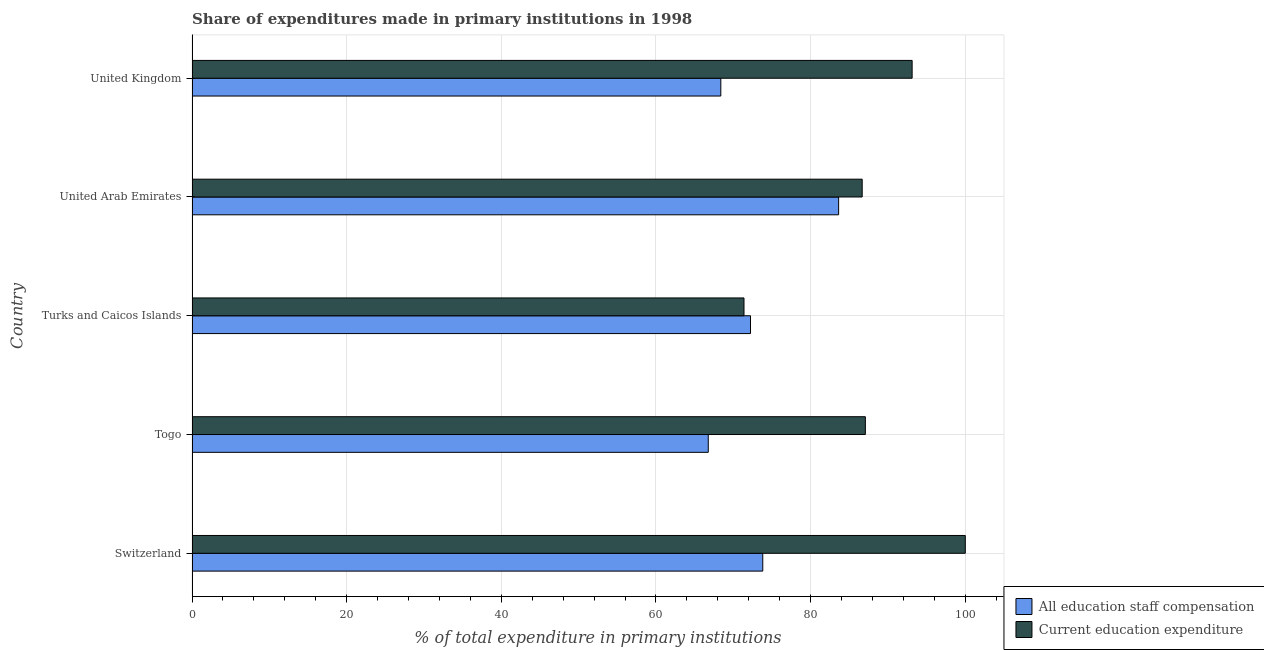How many different coloured bars are there?
Provide a succinct answer. 2. How many groups of bars are there?
Your response must be concise. 5. Are the number of bars per tick equal to the number of legend labels?
Ensure brevity in your answer.  Yes. Are the number of bars on each tick of the Y-axis equal?
Offer a very short reply. Yes. How many bars are there on the 1st tick from the top?
Provide a short and direct response. 2. What is the expenditure in staff compensation in Togo?
Your response must be concise. 66.76. Across all countries, what is the maximum expenditure in staff compensation?
Your response must be concise. 83.62. Across all countries, what is the minimum expenditure in staff compensation?
Make the answer very short. 66.76. In which country was the expenditure in staff compensation maximum?
Ensure brevity in your answer.  United Arab Emirates. In which country was the expenditure in staff compensation minimum?
Make the answer very short. Togo. What is the total expenditure in education in the graph?
Ensure brevity in your answer.  438.25. What is the difference between the expenditure in education in Switzerland and that in United Arab Emirates?
Give a very brief answer. 13.33. What is the difference between the expenditure in education in Turks and Caicos Islands and the expenditure in staff compensation in Switzerland?
Keep it short and to the point. -2.43. What is the average expenditure in staff compensation per country?
Your answer should be very brief. 72.96. What is the difference between the expenditure in education and expenditure in staff compensation in Switzerland?
Offer a terse response. 26.19. What is the ratio of the expenditure in staff compensation in Turks and Caicos Islands to that in United Kingdom?
Your answer should be very brief. 1.06. Is the difference between the expenditure in staff compensation in Turks and Caicos Islands and United Kingdom greater than the difference between the expenditure in education in Turks and Caicos Islands and United Kingdom?
Offer a very short reply. Yes. What is the difference between the highest and the second highest expenditure in education?
Ensure brevity in your answer.  6.87. What is the difference between the highest and the lowest expenditure in staff compensation?
Keep it short and to the point. 16.86. Is the sum of the expenditure in education in Switzerland and United Kingdom greater than the maximum expenditure in staff compensation across all countries?
Your response must be concise. Yes. What does the 1st bar from the top in Switzerland represents?
Offer a terse response. Current education expenditure. What does the 1st bar from the bottom in Togo represents?
Your answer should be very brief. All education staff compensation. Does the graph contain any zero values?
Make the answer very short. No. Does the graph contain grids?
Offer a very short reply. Yes. Where does the legend appear in the graph?
Your answer should be compact. Bottom right. How many legend labels are there?
Your answer should be very brief. 2. How are the legend labels stacked?
Your response must be concise. Vertical. What is the title of the graph?
Provide a short and direct response. Share of expenditures made in primary institutions in 1998. What is the label or title of the X-axis?
Your answer should be compact. % of total expenditure in primary institutions. What is the % of total expenditure in primary institutions in All education staff compensation in Switzerland?
Ensure brevity in your answer.  73.81. What is the % of total expenditure in primary institutions of All education staff compensation in Togo?
Ensure brevity in your answer.  66.76. What is the % of total expenditure in primary institutions in Current education expenditure in Togo?
Ensure brevity in your answer.  87.08. What is the % of total expenditure in primary institutions in All education staff compensation in Turks and Caicos Islands?
Your response must be concise. 72.22. What is the % of total expenditure in primary institutions of Current education expenditure in Turks and Caicos Islands?
Provide a succinct answer. 71.38. What is the % of total expenditure in primary institutions of All education staff compensation in United Arab Emirates?
Give a very brief answer. 83.62. What is the % of total expenditure in primary institutions in Current education expenditure in United Arab Emirates?
Your answer should be compact. 86.67. What is the % of total expenditure in primary institutions in All education staff compensation in United Kingdom?
Keep it short and to the point. 68.38. What is the % of total expenditure in primary institutions in Current education expenditure in United Kingdom?
Keep it short and to the point. 93.13. Across all countries, what is the maximum % of total expenditure in primary institutions in All education staff compensation?
Keep it short and to the point. 83.62. Across all countries, what is the maximum % of total expenditure in primary institutions of Current education expenditure?
Ensure brevity in your answer.  100. Across all countries, what is the minimum % of total expenditure in primary institutions of All education staff compensation?
Offer a terse response. 66.76. Across all countries, what is the minimum % of total expenditure in primary institutions in Current education expenditure?
Provide a short and direct response. 71.38. What is the total % of total expenditure in primary institutions of All education staff compensation in the graph?
Keep it short and to the point. 364.8. What is the total % of total expenditure in primary institutions of Current education expenditure in the graph?
Provide a short and direct response. 438.25. What is the difference between the % of total expenditure in primary institutions of All education staff compensation in Switzerland and that in Togo?
Keep it short and to the point. 7.05. What is the difference between the % of total expenditure in primary institutions of Current education expenditure in Switzerland and that in Togo?
Offer a terse response. 12.92. What is the difference between the % of total expenditure in primary institutions of All education staff compensation in Switzerland and that in Turks and Caicos Islands?
Your response must be concise. 1.59. What is the difference between the % of total expenditure in primary institutions in Current education expenditure in Switzerland and that in Turks and Caicos Islands?
Make the answer very short. 28.62. What is the difference between the % of total expenditure in primary institutions in All education staff compensation in Switzerland and that in United Arab Emirates?
Make the answer very short. -9.81. What is the difference between the % of total expenditure in primary institutions of Current education expenditure in Switzerland and that in United Arab Emirates?
Offer a terse response. 13.33. What is the difference between the % of total expenditure in primary institutions in All education staff compensation in Switzerland and that in United Kingdom?
Your answer should be compact. 5.42. What is the difference between the % of total expenditure in primary institutions of Current education expenditure in Switzerland and that in United Kingdom?
Ensure brevity in your answer.  6.87. What is the difference between the % of total expenditure in primary institutions of All education staff compensation in Togo and that in Turks and Caicos Islands?
Give a very brief answer. -5.46. What is the difference between the % of total expenditure in primary institutions in Current education expenditure in Togo and that in Turks and Caicos Islands?
Your response must be concise. 15.7. What is the difference between the % of total expenditure in primary institutions in All education staff compensation in Togo and that in United Arab Emirates?
Give a very brief answer. -16.86. What is the difference between the % of total expenditure in primary institutions of Current education expenditure in Togo and that in United Arab Emirates?
Your answer should be very brief. 0.41. What is the difference between the % of total expenditure in primary institutions of All education staff compensation in Togo and that in United Kingdom?
Your answer should be compact. -1.62. What is the difference between the % of total expenditure in primary institutions in Current education expenditure in Togo and that in United Kingdom?
Make the answer very short. -6.05. What is the difference between the % of total expenditure in primary institutions in All education staff compensation in Turks and Caicos Islands and that in United Arab Emirates?
Your response must be concise. -11.4. What is the difference between the % of total expenditure in primary institutions in Current education expenditure in Turks and Caicos Islands and that in United Arab Emirates?
Ensure brevity in your answer.  -15.29. What is the difference between the % of total expenditure in primary institutions in All education staff compensation in Turks and Caicos Islands and that in United Kingdom?
Provide a succinct answer. 3.84. What is the difference between the % of total expenditure in primary institutions of Current education expenditure in Turks and Caicos Islands and that in United Kingdom?
Give a very brief answer. -21.74. What is the difference between the % of total expenditure in primary institutions in All education staff compensation in United Arab Emirates and that in United Kingdom?
Your response must be concise. 15.24. What is the difference between the % of total expenditure in primary institutions of Current education expenditure in United Arab Emirates and that in United Kingdom?
Your answer should be very brief. -6.46. What is the difference between the % of total expenditure in primary institutions of All education staff compensation in Switzerland and the % of total expenditure in primary institutions of Current education expenditure in Togo?
Your answer should be compact. -13.27. What is the difference between the % of total expenditure in primary institutions of All education staff compensation in Switzerland and the % of total expenditure in primary institutions of Current education expenditure in Turks and Caicos Islands?
Your answer should be compact. 2.43. What is the difference between the % of total expenditure in primary institutions in All education staff compensation in Switzerland and the % of total expenditure in primary institutions in Current education expenditure in United Arab Emirates?
Ensure brevity in your answer.  -12.86. What is the difference between the % of total expenditure in primary institutions of All education staff compensation in Switzerland and the % of total expenditure in primary institutions of Current education expenditure in United Kingdom?
Your response must be concise. -19.32. What is the difference between the % of total expenditure in primary institutions of All education staff compensation in Togo and the % of total expenditure in primary institutions of Current education expenditure in Turks and Caicos Islands?
Keep it short and to the point. -4.62. What is the difference between the % of total expenditure in primary institutions in All education staff compensation in Togo and the % of total expenditure in primary institutions in Current education expenditure in United Arab Emirates?
Give a very brief answer. -19.91. What is the difference between the % of total expenditure in primary institutions in All education staff compensation in Togo and the % of total expenditure in primary institutions in Current education expenditure in United Kingdom?
Offer a terse response. -26.36. What is the difference between the % of total expenditure in primary institutions in All education staff compensation in Turks and Caicos Islands and the % of total expenditure in primary institutions in Current education expenditure in United Arab Emirates?
Your response must be concise. -14.44. What is the difference between the % of total expenditure in primary institutions in All education staff compensation in Turks and Caicos Islands and the % of total expenditure in primary institutions in Current education expenditure in United Kingdom?
Offer a terse response. -20.9. What is the difference between the % of total expenditure in primary institutions in All education staff compensation in United Arab Emirates and the % of total expenditure in primary institutions in Current education expenditure in United Kingdom?
Your response must be concise. -9.51. What is the average % of total expenditure in primary institutions in All education staff compensation per country?
Your response must be concise. 72.96. What is the average % of total expenditure in primary institutions of Current education expenditure per country?
Your answer should be compact. 87.65. What is the difference between the % of total expenditure in primary institutions in All education staff compensation and % of total expenditure in primary institutions in Current education expenditure in Switzerland?
Your response must be concise. -26.19. What is the difference between the % of total expenditure in primary institutions in All education staff compensation and % of total expenditure in primary institutions in Current education expenditure in Togo?
Your answer should be very brief. -20.32. What is the difference between the % of total expenditure in primary institutions in All education staff compensation and % of total expenditure in primary institutions in Current education expenditure in Turks and Caicos Islands?
Offer a terse response. 0.84. What is the difference between the % of total expenditure in primary institutions in All education staff compensation and % of total expenditure in primary institutions in Current education expenditure in United Arab Emirates?
Provide a short and direct response. -3.05. What is the difference between the % of total expenditure in primary institutions of All education staff compensation and % of total expenditure in primary institutions of Current education expenditure in United Kingdom?
Keep it short and to the point. -24.74. What is the ratio of the % of total expenditure in primary institutions of All education staff compensation in Switzerland to that in Togo?
Ensure brevity in your answer.  1.11. What is the ratio of the % of total expenditure in primary institutions of Current education expenditure in Switzerland to that in Togo?
Your answer should be compact. 1.15. What is the ratio of the % of total expenditure in primary institutions in All education staff compensation in Switzerland to that in Turks and Caicos Islands?
Ensure brevity in your answer.  1.02. What is the ratio of the % of total expenditure in primary institutions in Current education expenditure in Switzerland to that in Turks and Caicos Islands?
Make the answer very short. 1.4. What is the ratio of the % of total expenditure in primary institutions of All education staff compensation in Switzerland to that in United Arab Emirates?
Keep it short and to the point. 0.88. What is the ratio of the % of total expenditure in primary institutions in Current education expenditure in Switzerland to that in United Arab Emirates?
Provide a succinct answer. 1.15. What is the ratio of the % of total expenditure in primary institutions of All education staff compensation in Switzerland to that in United Kingdom?
Your answer should be compact. 1.08. What is the ratio of the % of total expenditure in primary institutions of Current education expenditure in Switzerland to that in United Kingdom?
Offer a very short reply. 1.07. What is the ratio of the % of total expenditure in primary institutions of All education staff compensation in Togo to that in Turks and Caicos Islands?
Your answer should be compact. 0.92. What is the ratio of the % of total expenditure in primary institutions in Current education expenditure in Togo to that in Turks and Caicos Islands?
Your answer should be very brief. 1.22. What is the ratio of the % of total expenditure in primary institutions in All education staff compensation in Togo to that in United Arab Emirates?
Offer a terse response. 0.8. What is the ratio of the % of total expenditure in primary institutions of Current education expenditure in Togo to that in United Arab Emirates?
Your answer should be compact. 1. What is the ratio of the % of total expenditure in primary institutions in All education staff compensation in Togo to that in United Kingdom?
Your answer should be very brief. 0.98. What is the ratio of the % of total expenditure in primary institutions of Current education expenditure in Togo to that in United Kingdom?
Offer a very short reply. 0.94. What is the ratio of the % of total expenditure in primary institutions of All education staff compensation in Turks and Caicos Islands to that in United Arab Emirates?
Give a very brief answer. 0.86. What is the ratio of the % of total expenditure in primary institutions of Current education expenditure in Turks and Caicos Islands to that in United Arab Emirates?
Offer a terse response. 0.82. What is the ratio of the % of total expenditure in primary institutions of All education staff compensation in Turks and Caicos Islands to that in United Kingdom?
Make the answer very short. 1.06. What is the ratio of the % of total expenditure in primary institutions in Current education expenditure in Turks and Caicos Islands to that in United Kingdom?
Offer a very short reply. 0.77. What is the ratio of the % of total expenditure in primary institutions in All education staff compensation in United Arab Emirates to that in United Kingdom?
Provide a succinct answer. 1.22. What is the ratio of the % of total expenditure in primary institutions of Current education expenditure in United Arab Emirates to that in United Kingdom?
Ensure brevity in your answer.  0.93. What is the difference between the highest and the second highest % of total expenditure in primary institutions in All education staff compensation?
Provide a succinct answer. 9.81. What is the difference between the highest and the second highest % of total expenditure in primary institutions of Current education expenditure?
Your response must be concise. 6.87. What is the difference between the highest and the lowest % of total expenditure in primary institutions of All education staff compensation?
Give a very brief answer. 16.86. What is the difference between the highest and the lowest % of total expenditure in primary institutions of Current education expenditure?
Offer a very short reply. 28.62. 